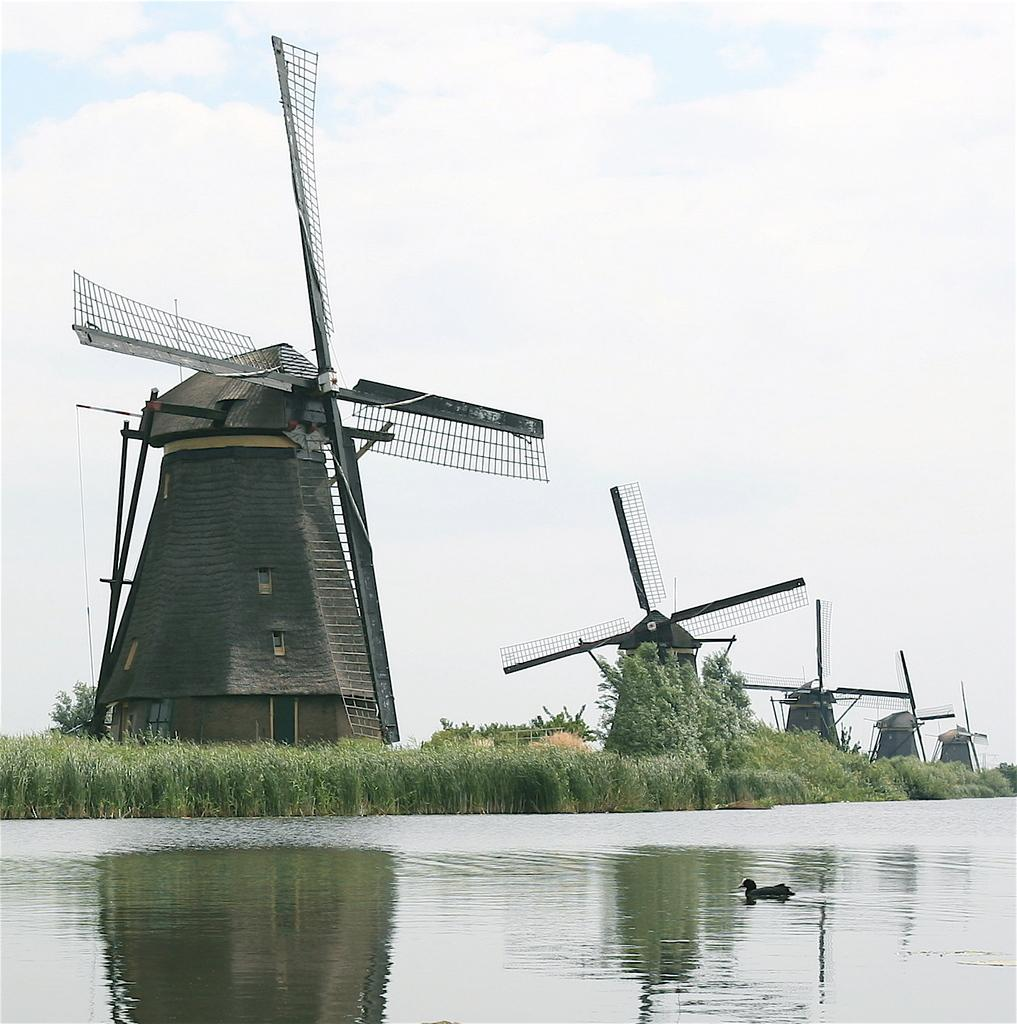What type of structures can be seen in the image? There are windmills in the image. What animal is in the water in the image? There is a duck in the water. What type of vegetation is visible in the image? Grass plants and trees are visible in the image. How would you describe the sky in the image? The sky is cloudy in the image. What type of magic is being performed by the windmills in the image? There is no magic being performed by the windmills in the image; they are simply structures. How does the acoustics of the duck's quack sound in the image? There is no sound in the image, so it is not possible to determine the acoustics of the duck's quack. 